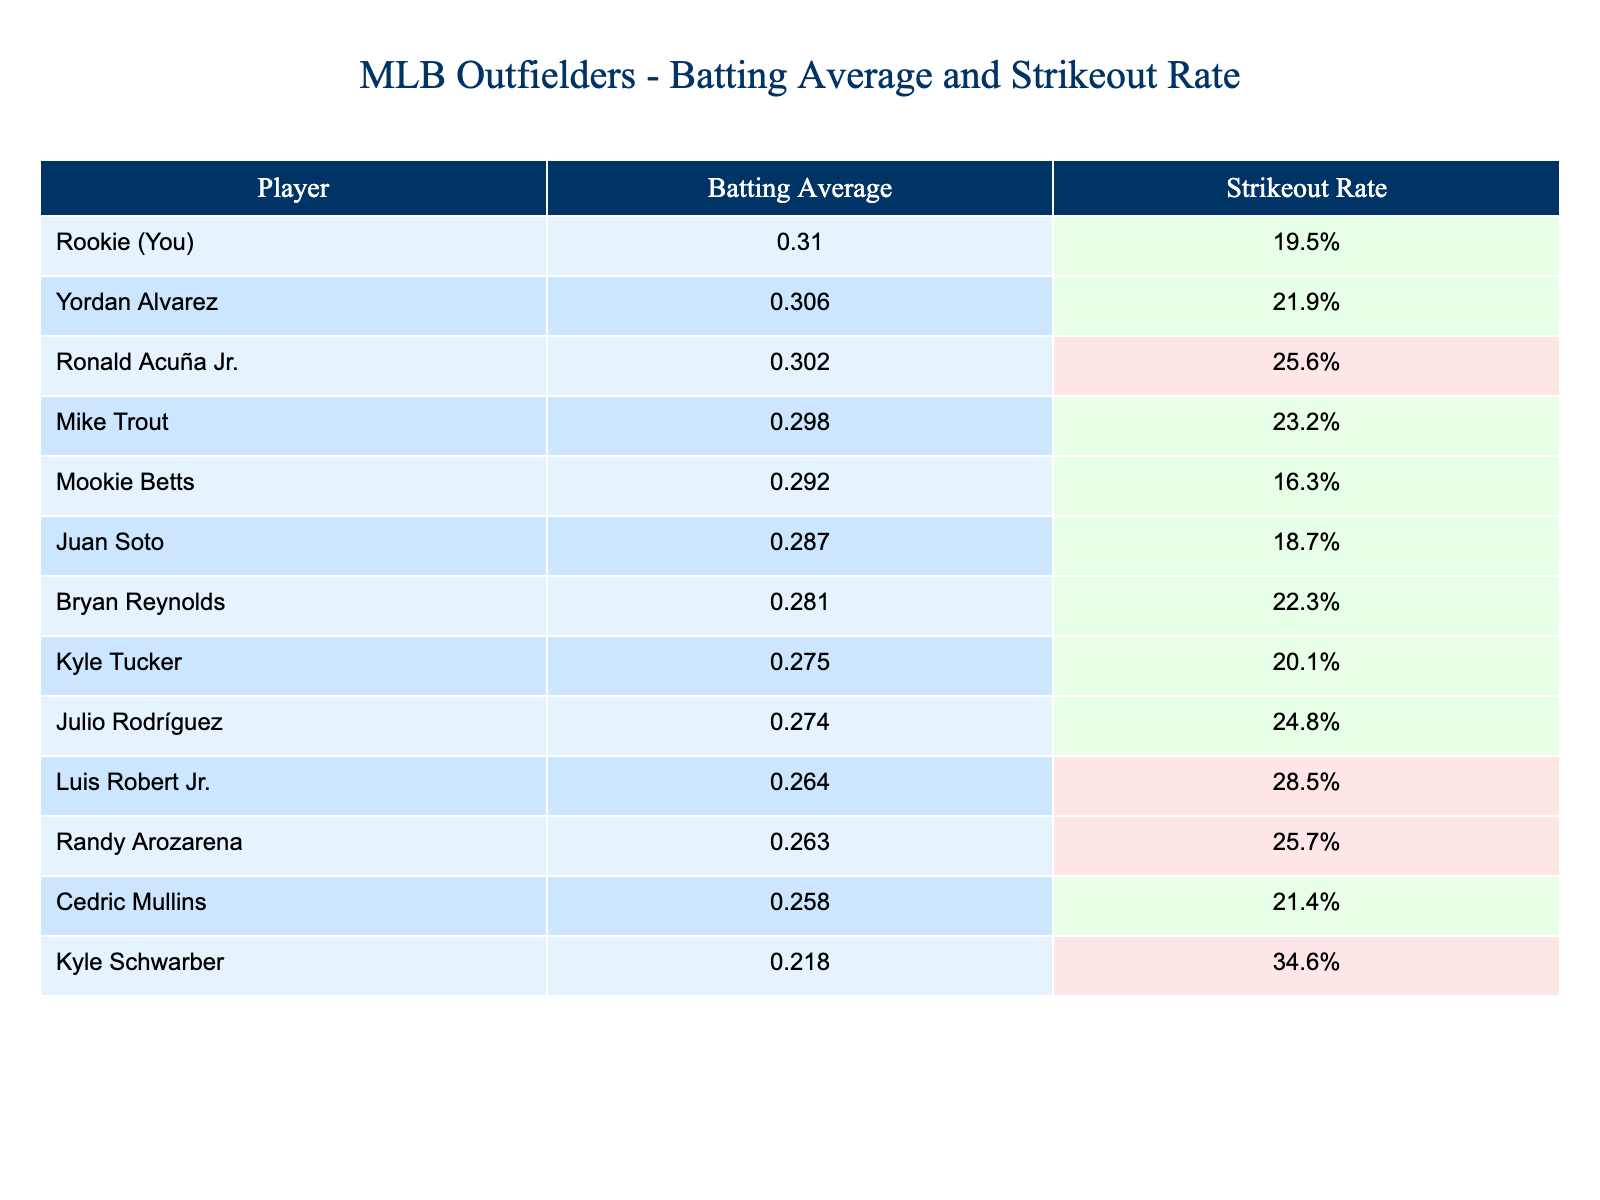What is the highest batting average among the players listed? By examining the batting averages listed in the table, the highest value is for Yordan Alvarez at 0.306.
Answer: 0.306 Who has the lowest strikeout rate? The lowest strikeout rate is found by looking through the strikeout rates in the table, which is attributed to Mookie Betts at 16.3%.
Answer: 16.3% How does your batting average compare to Kyle Schwarber's? Your batting average is 0.310 while Kyle Schwarber's is 0.218. Subtracting these gives a difference of 0.310 - 0.218 = 0.092, meaning yours is 0.092 higher.
Answer: 0.092 Is it true that Ronald Acuña Jr. has a better batting average than Juan Soto? Checking the batting averages for both players shows Ronald Acuña Jr. at 0.302 and Juan Soto at 0.287. Since 0.302 is greater than 0.287, the statement is true.
Answer: True What is the average strikeout rate of players with a batting average above 0.290? The players above 0.290 are Mike Trout, Ronald Acuña Jr., Mookie Betts, Yordan Alvarez, and you. Their strikeout rates are 23.2%, 25.6%, 16.3%, 21.9%, and 19.5%. Adding these gives 106.5%, and dividing by 5 gives an average of 21.3%.
Answer: 21.3% Who has a higher batting average, Luis Robert Jr. or Kyle Tucker? By comparing their batting averages, Luis Robert Jr. is at 0.264 and Kyle Tucker at 0.275. Since 0.275 is higher, Kyle Tucker has the better average.
Answer: Kyle Tucker What is the difference in strikeout rate between the player with the highest average and yourself? The player with the highest batting average is Yordan Alvarez at 0.306, and your strikeout rate is 19.5%. Yordan Alvarez's strikeout rate is 21.9%. The difference is 21.9% - 19.5% = 2.4%.
Answer: 2.4% Which outfielder has both a lower batting average and a higher strikeout rate than you? You have a batting average of 0.310. Looking through the table, Luis Robert Jr. has a lower average (0.264) and a higher strikeout rate (28.5%).
Answer: Luis Robert Jr What percentage of players in the table have a strikeout rate above 25%? The players with strikeout rates above 25% are Ronald Acuña Jr., Kyle Schwarber, and Randy Arozarena (3 players). There are 15 players in total. Therefore, the percentage is (3/15) * 100 = 20%.
Answer: 20% Which player has a strikeout rate closest to yours? Your strikeout rate is 19.5%. Looking at the table, Mookie Betts has a strikeout rate of 16.3%, and Juan Soto has 18.7%. The closest is Juan Soto at 18.7%, which is only 0.8% lower than yours.
Answer: Juan Soto 